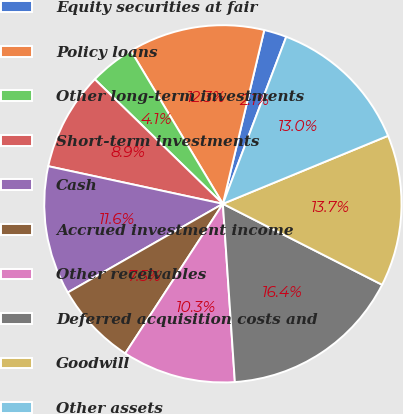Convert chart. <chart><loc_0><loc_0><loc_500><loc_500><pie_chart><fcel>Equity securities at fair<fcel>Policy loans<fcel>Other long-term investments<fcel>Short-term investments<fcel>Cash<fcel>Accrued investment income<fcel>Other receivables<fcel>Deferred acquisition costs and<fcel>Goodwill<fcel>Other assets<nl><fcel>2.05%<fcel>12.33%<fcel>4.11%<fcel>8.9%<fcel>11.64%<fcel>7.53%<fcel>10.27%<fcel>16.44%<fcel>13.7%<fcel>13.01%<nl></chart> 